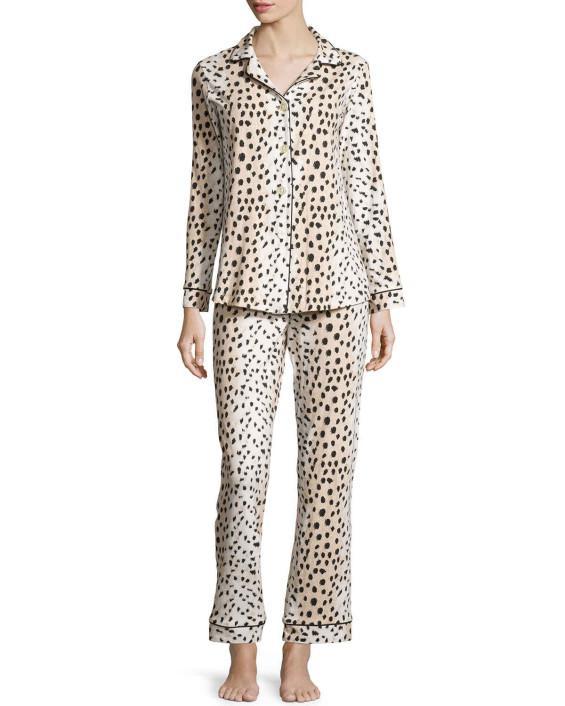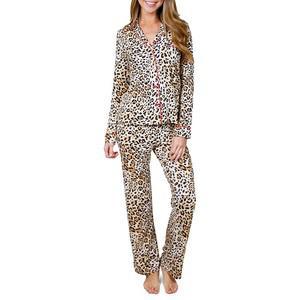The first image is the image on the left, the second image is the image on the right. Analyze the images presented: Is the assertion "The female in the right image is standing with her feet crossed." valid? Answer yes or no. No. 